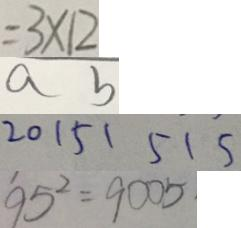Convert formula to latex. <formula><loc_0><loc_0><loc_500><loc_500>= 3 \times 1 2 
 a b 
 2 0 1 5 1 5 1 5 
 9 5 ^ { 2 } = 9 0 0 5 \cdot</formula> 